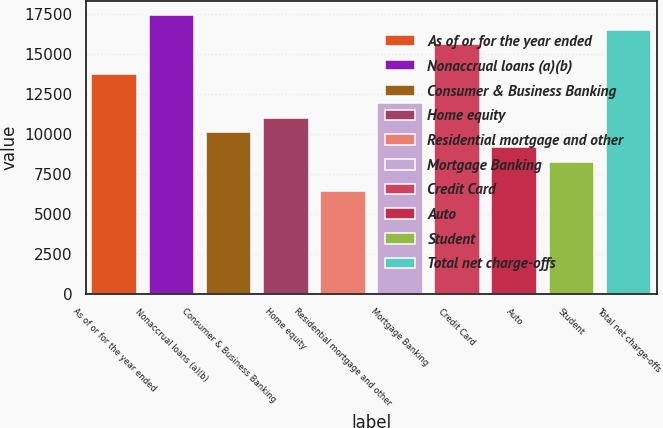Convert chart. <chart><loc_0><loc_0><loc_500><loc_500><bar_chart><fcel>As of or for the year ended<fcel>Nonaccrual loans (a)(b)<fcel>Consumer & Business Banking<fcel>Home equity<fcel>Residential mortgage and other<fcel>Mortgage Banking<fcel>Credit Card<fcel>Auto<fcel>Student<fcel>Total net charge-offs<nl><fcel>13747.4<fcel>17413.3<fcel>10081.5<fcel>10997.9<fcel>6415.54<fcel>11914.4<fcel>15580.3<fcel>9164.98<fcel>8248.5<fcel>16496.8<nl></chart> 